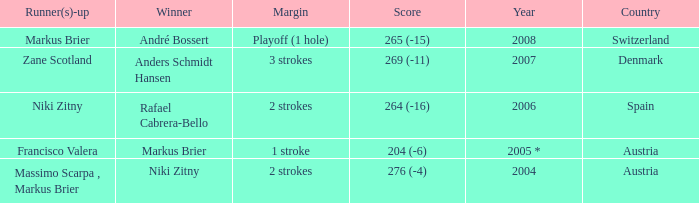Who was the runner-up when the year was 2008? Markus Brier. 